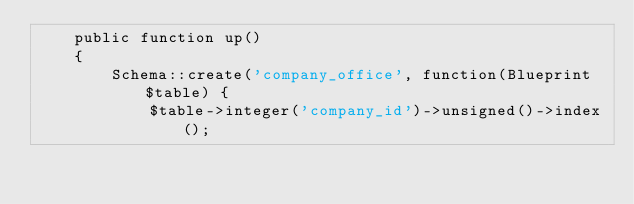<code> <loc_0><loc_0><loc_500><loc_500><_PHP_>    public function up()
    {
        Schema::create('company_office', function(Blueprint $table) {
            $table->integer('company_id')->unsigned()->index();</code> 